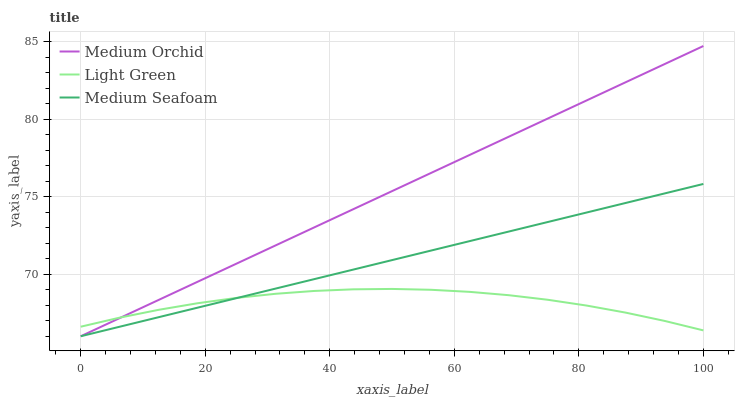Does Light Green have the minimum area under the curve?
Answer yes or no. Yes. Does Medium Orchid have the maximum area under the curve?
Answer yes or no. Yes. Does Medium Seafoam have the minimum area under the curve?
Answer yes or no. No. Does Medium Seafoam have the maximum area under the curve?
Answer yes or no. No. Is Medium Orchid the smoothest?
Answer yes or no. Yes. Is Light Green the roughest?
Answer yes or no. Yes. Is Light Green the smoothest?
Answer yes or no. No. Is Medium Seafoam the roughest?
Answer yes or no. No. Does Medium Orchid have the lowest value?
Answer yes or no. Yes. Does Light Green have the lowest value?
Answer yes or no. No. Does Medium Orchid have the highest value?
Answer yes or no. Yes. Does Medium Seafoam have the highest value?
Answer yes or no. No. Does Medium Seafoam intersect Light Green?
Answer yes or no. Yes. Is Medium Seafoam less than Light Green?
Answer yes or no. No. Is Medium Seafoam greater than Light Green?
Answer yes or no. No. 